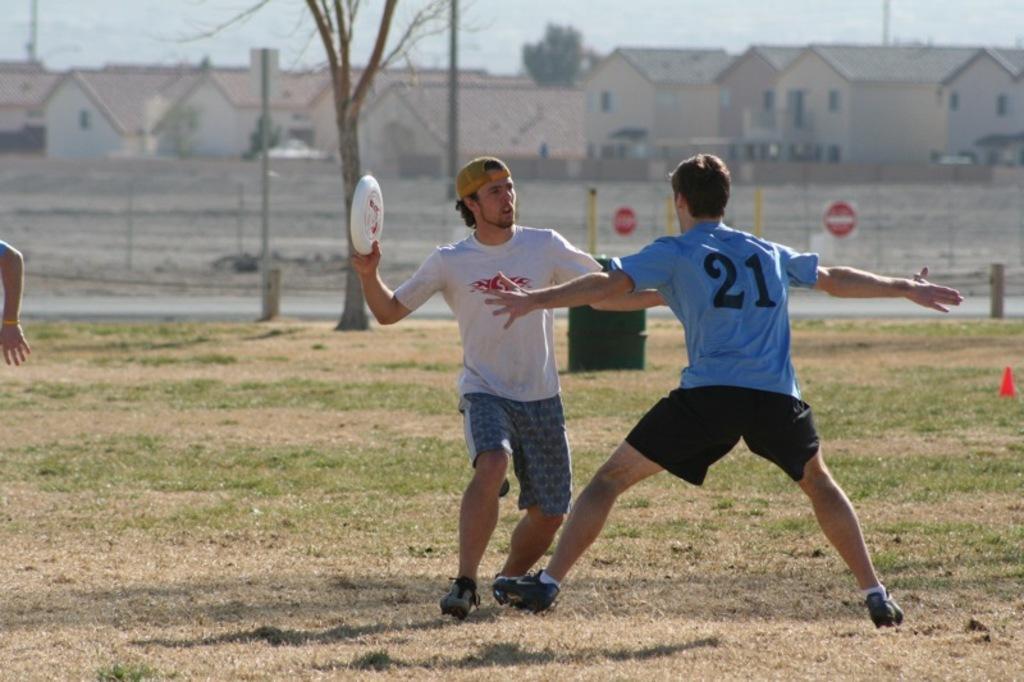Can you describe this image briefly? In this image in the center there are persons playing. There is grass on the ground. In the background there is a fence and there are buildings and there are trees. On the left side the hand of the person is visible. 